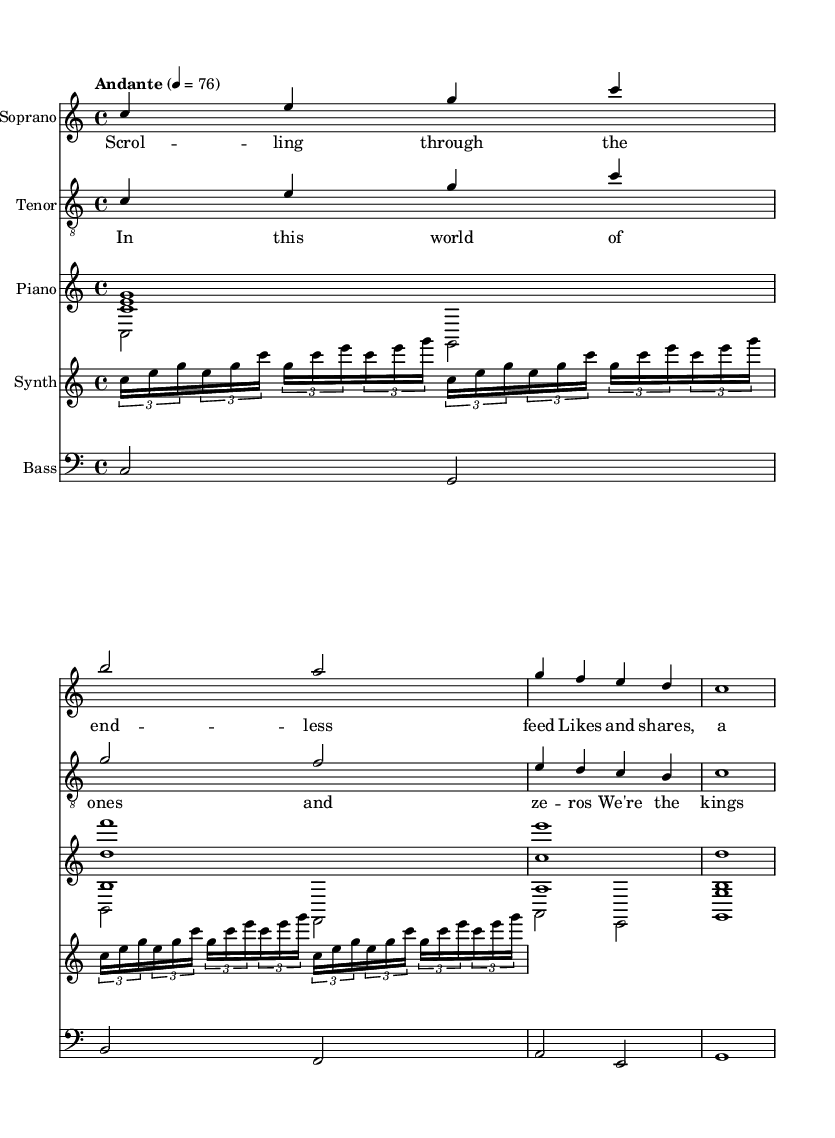What is the key signature of this music? The key signature is indicated by the absence of sharps or flats in the signature area. Therefore, it is in C major.
Answer: C major What is the time signature of this piece? The time signature is represented by the numbers at the beginning of the score, which indicates how many beats are in each measure. It is 4 over 4, meaning there are four beats per measure.
Answer: 4/4 What is the tempo marking for this music? The tempo is shown with a term and a metronome marking. In this case, it is "Andante" with a BPM of 76, indicating a moderate pace.
Answer: Andante, 76 How many voices are present in the music? By examining the score, we see separate staves for soprano, tenor, and additional instrumental parts, suggesting at least two vocal parts are designated.
Answer: Two What musical roles do the synthesizer and electric bass play in this opera? The synthesizer adds electronic texture to the opera, while the electric bass provides harmonic support and grounding to the piece, contributing to the overall sound.
Answer: Texture and harmony What is the lyrical content of the verse and chorus? The verse lyrics discuss themes of scrolling and digital interaction, while the chorus reflects an idea of empowerment in a digital world. The content reveals the opera's focus on social media and the digital age.
Answer: Digital interaction and empowerment Which voice part has the highest range in this score? By comparing the written pitches in the staves, the soprano part reaches the highest notes, often above middle C.
Answer: Soprano 